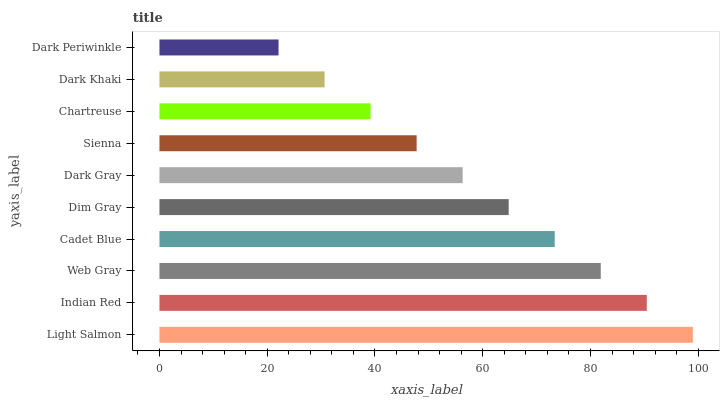Is Dark Periwinkle the minimum?
Answer yes or no. Yes. Is Light Salmon the maximum?
Answer yes or no. Yes. Is Indian Red the minimum?
Answer yes or no. No. Is Indian Red the maximum?
Answer yes or no. No. Is Light Salmon greater than Indian Red?
Answer yes or no. Yes. Is Indian Red less than Light Salmon?
Answer yes or no. Yes. Is Indian Red greater than Light Salmon?
Answer yes or no. No. Is Light Salmon less than Indian Red?
Answer yes or no. No. Is Dim Gray the high median?
Answer yes or no. Yes. Is Dark Gray the low median?
Answer yes or no. Yes. Is Sienna the high median?
Answer yes or no. No. Is Web Gray the low median?
Answer yes or no. No. 